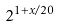Convert formula to latex. <formula><loc_0><loc_0><loc_500><loc_500>2 ^ { 1 + x / 2 0 }</formula> 